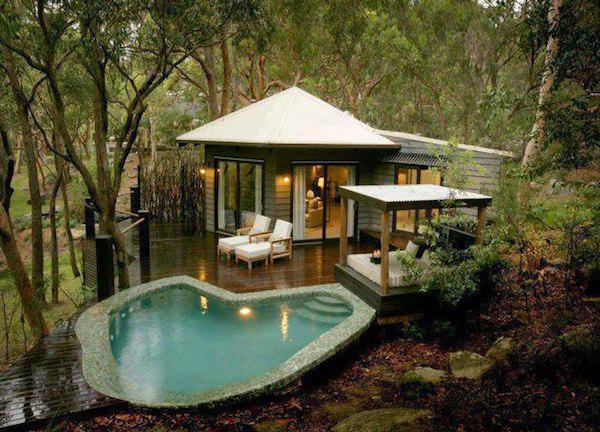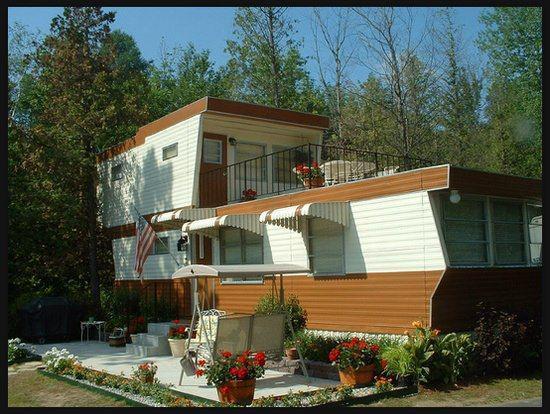The first image is the image on the left, the second image is the image on the right. Assess this claim about the two images: "All images show only the exteriors of homes.". Correct or not? Answer yes or no. Yes. 